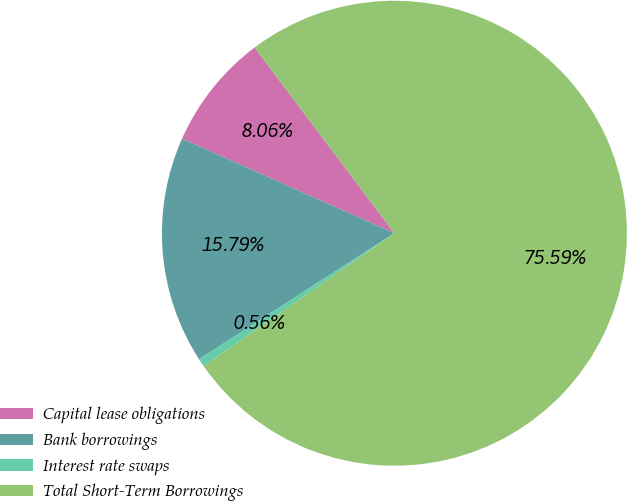Convert chart. <chart><loc_0><loc_0><loc_500><loc_500><pie_chart><fcel>Capital lease obligations<fcel>Bank borrowings<fcel>Interest rate swaps<fcel>Total Short-Term Borrowings<nl><fcel>8.06%<fcel>15.79%<fcel>0.56%<fcel>75.58%<nl></chart> 